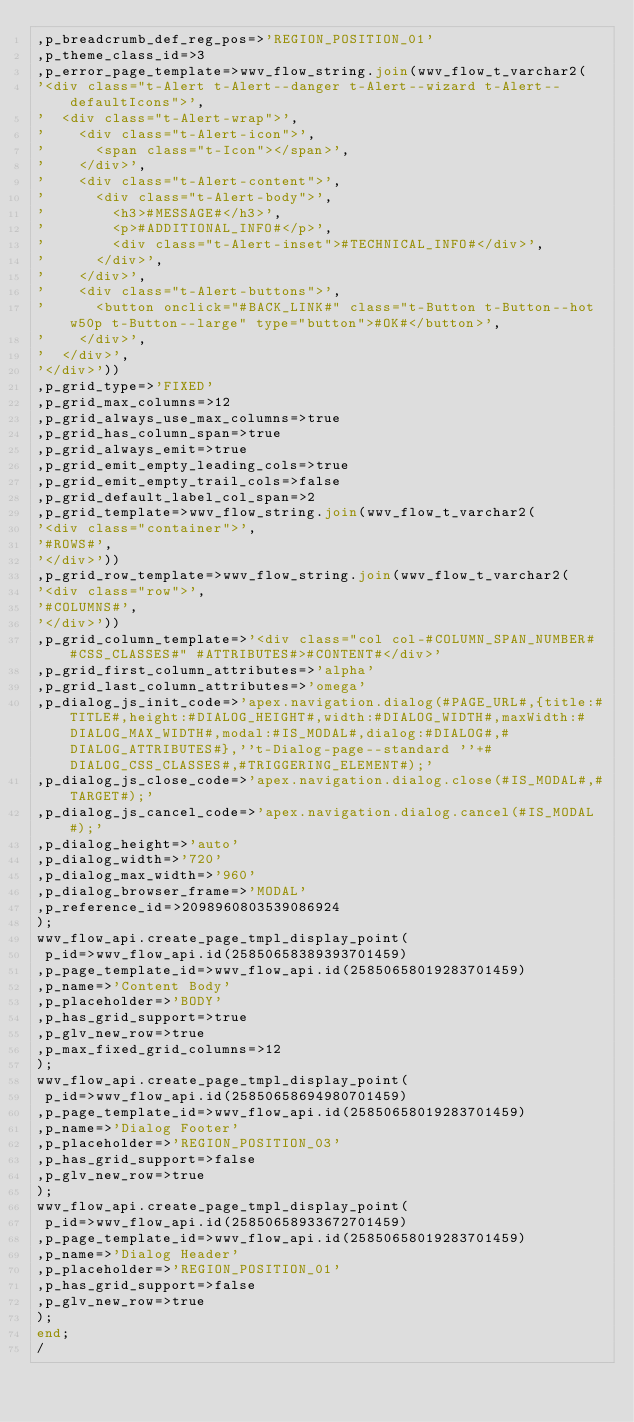<code> <loc_0><loc_0><loc_500><loc_500><_SQL_>,p_breadcrumb_def_reg_pos=>'REGION_POSITION_01'
,p_theme_class_id=>3
,p_error_page_template=>wwv_flow_string.join(wwv_flow_t_varchar2(
'<div class="t-Alert t-Alert--danger t-Alert--wizard t-Alert--defaultIcons">',
'  <div class="t-Alert-wrap">',
'    <div class="t-Alert-icon">',
'      <span class="t-Icon"></span>',
'    </div>',
'    <div class="t-Alert-content">',
'      <div class="t-Alert-body">',
'        <h3>#MESSAGE#</h3>',
'        <p>#ADDITIONAL_INFO#</p>',
'        <div class="t-Alert-inset">#TECHNICAL_INFO#</div>',
'      </div>',
'    </div>',
'    <div class="t-Alert-buttons">',
'      <button onclick="#BACK_LINK#" class="t-Button t-Button--hot w50p t-Button--large" type="button">#OK#</button>',
'    </div>',
'  </div>',
'</div>'))
,p_grid_type=>'FIXED'
,p_grid_max_columns=>12
,p_grid_always_use_max_columns=>true
,p_grid_has_column_span=>true
,p_grid_always_emit=>true
,p_grid_emit_empty_leading_cols=>true
,p_grid_emit_empty_trail_cols=>false
,p_grid_default_label_col_span=>2
,p_grid_template=>wwv_flow_string.join(wwv_flow_t_varchar2(
'<div class="container">',
'#ROWS#',
'</div>'))
,p_grid_row_template=>wwv_flow_string.join(wwv_flow_t_varchar2(
'<div class="row">',
'#COLUMNS#',
'</div>'))
,p_grid_column_template=>'<div class="col col-#COLUMN_SPAN_NUMBER# #CSS_CLASSES#" #ATTRIBUTES#>#CONTENT#</div>'
,p_grid_first_column_attributes=>'alpha'
,p_grid_last_column_attributes=>'omega'
,p_dialog_js_init_code=>'apex.navigation.dialog(#PAGE_URL#,{title:#TITLE#,height:#DIALOG_HEIGHT#,width:#DIALOG_WIDTH#,maxWidth:#DIALOG_MAX_WIDTH#,modal:#IS_MODAL#,dialog:#DIALOG#,#DIALOG_ATTRIBUTES#},''t-Dialog-page--standard ''+#DIALOG_CSS_CLASSES#,#TRIGGERING_ELEMENT#);'
,p_dialog_js_close_code=>'apex.navigation.dialog.close(#IS_MODAL#,#TARGET#);'
,p_dialog_js_cancel_code=>'apex.navigation.dialog.cancel(#IS_MODAL#);'
,p_dialog_height=>'auto'
,p_dialog_width=>'720'
,p_dialog_max_width=>'960'
,p_dialog_browser_frame=>'MODAL'
,p_reference_id=>2098960803539086924
);
wwv_flow_api.create_page_tmpl_display_point(
 p_id=>wwv_flow_api.id(25850658389393701459)
,p_page_template_id=>wwv_flow_api.id(25850658019283701459)
,p_name=>'Content Body'
,p_placeholder=>'BODY'
,p_has_grid_support=>true
,p_glv_new_row=>true
,p_max_fixed_grid_columns=>12
);
wwv_flow_api.create_page_tmpl_display_point(
 p_id=>wwv_flow_api.id(25850658694980701459)
,p_page_template_id=>wwv_flow_api.id(25850658019283701459)
,p_name=>'Dialog Footer'
,p_placeholder=>'REGION_POSITION_03'
,p_has_grid_support=>false
,p_glv_new_row=>true
);
wwv_flow_api.create_page_tmpl_display_point(
 p_id=>wwv_flow_api.id(25850658933672701459)
,p_page_template_id=>wwv_flow_api.id(25850658019283701459)
,p_name=>'Dialog Header'
,p_placeholder=>'REGION_POSITION_01'
,p_has_grid_support=>false
,p_glv_new_row=>true
);
end;
/
</code> 